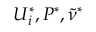<formula> <loc_0><loc_0><loc_500><loc_500>U _ { i } ^ { * } , P ^ { * } , \tilde { \nu } ^ { * }</formula> 